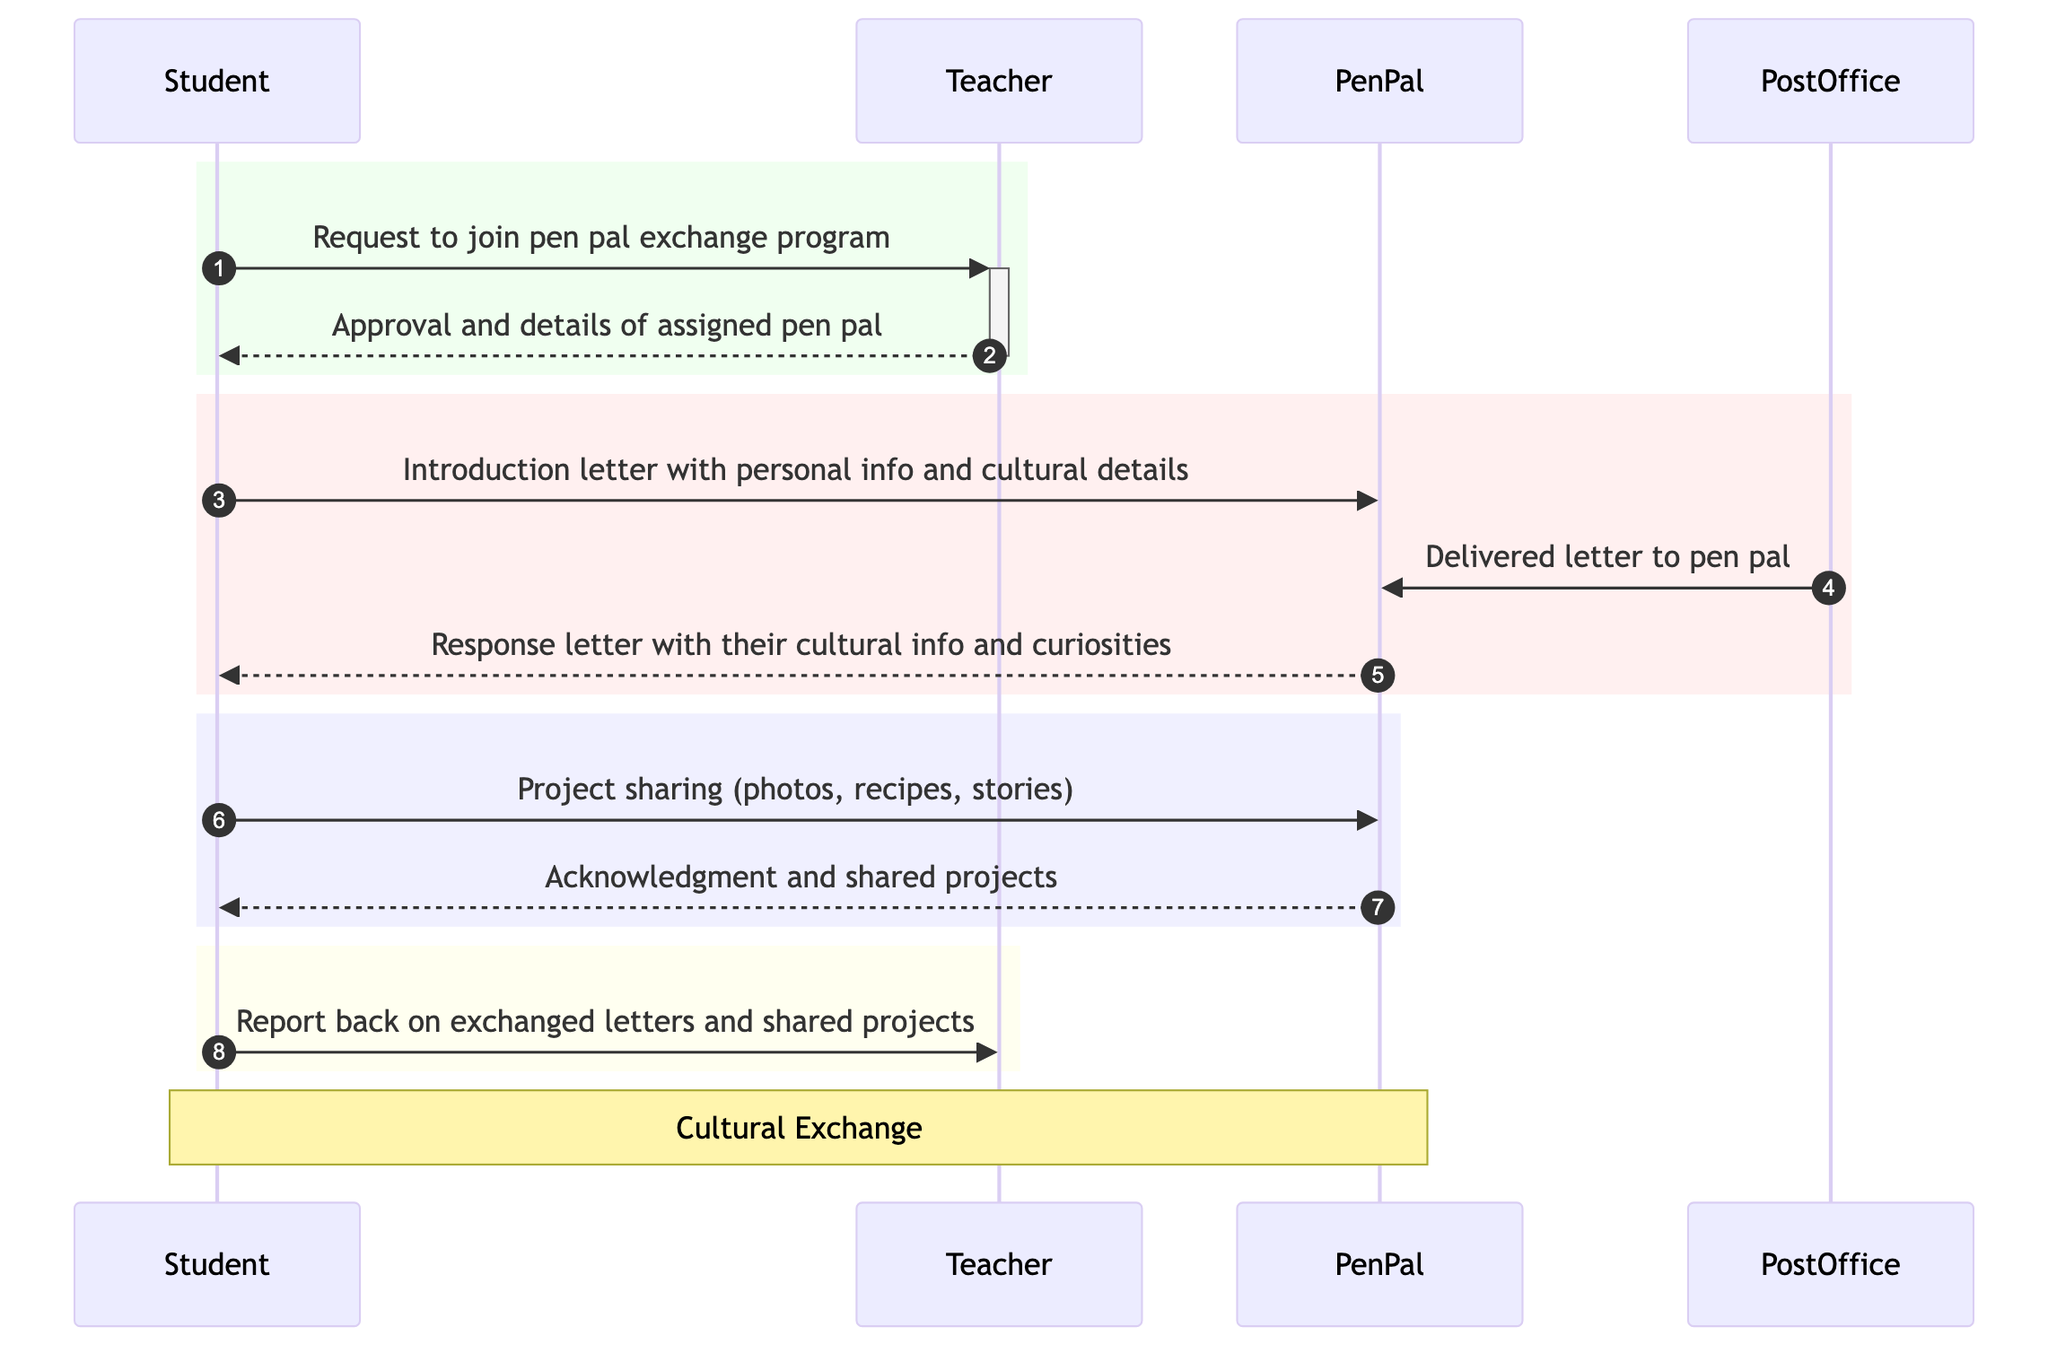What is the first action taken by the Student? The Student initiates the process by sending a request to join the pen pal exchange program to the Teacher. This is the first interaction shown in the diagram, highlighting the starting point of the sequence.
Answer: Request to join pen pal exchange program How many participants are involved in the diagram? There are four participants in the diagram: Student, Teacher, PenPal, and PostOffice. Each participant engages in sending or receiving messages throughout the sequence, making the total count four.
Answer: 4 What does the Student send to the PenPal in the second interaction? In the second interaction, after receiving approval, the Student sends an introduction letter with personal information and cultural details to the PenPal. This message represents the Student's effort to start a conversation and share about themselves.
Answer: Introduction letter with personal info and cultural details Which participant delivers the letter to the PenPal? The PostOffice is responsible for delivering the letter from the Student to the PenPal. This action indicates the role of the PostOffice in facilitating communication between the two parties.
Answer: Delivered letter to pen pal What does the Student report back to the Teacher after exchanging letters? After exchanging letters and sharing projects, the Student reports back to the Teacher. This step completes the communication cycle and shows the Student's reflection on the pen pal experience.
Answer: Report back on exchanged letters and shared projects What type of exchange occurs between the Student and PenPal? A cultural exchange occurs between the Student and the PenPal as they share personal information, curiosities, and projects related to their respective cultures. This exchange is central to the program's objective.
Answer: Cultural Exchange How many letters are sent from Student to PenPal? There are two letters sent from the Student to the PenPal: the introduction letter and the project-sharing message. Each letter represents a distinct stage in their ongoing communication.
Answer: 2 What does the PenPal send back to the Student after receiving the introduction letter? The PenPal sends a response letter that includes their cultural information and curiosities back to the Student. This response continues the dialogue initiated by the Student's introduction.
Answer: Response letter with their cultural info and curiosities What kind of projects does the Student share with the PenPal? The Student shares various projects such as photos of local landmarks, recipes, or stories. This action reflects the Student's engagement in the cultural exchange aspect of the program.
Answer: Project sharing (photos, recipes, stories) 